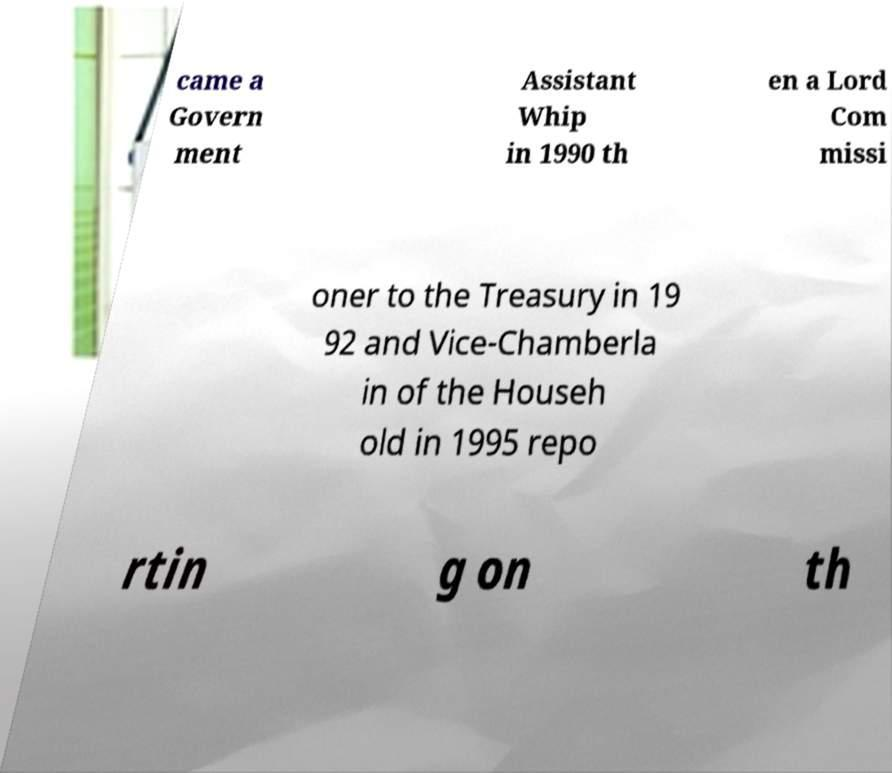For documentation purposes, I need the text within this image transcribed. Could you provide that? came a Govern ment Assistant Whip in 1990 th en a Lord Com missi oner to the Treasury in 19 92 and Vice-Chamberla in of the Househ old in 1995 repo rtin g on th 